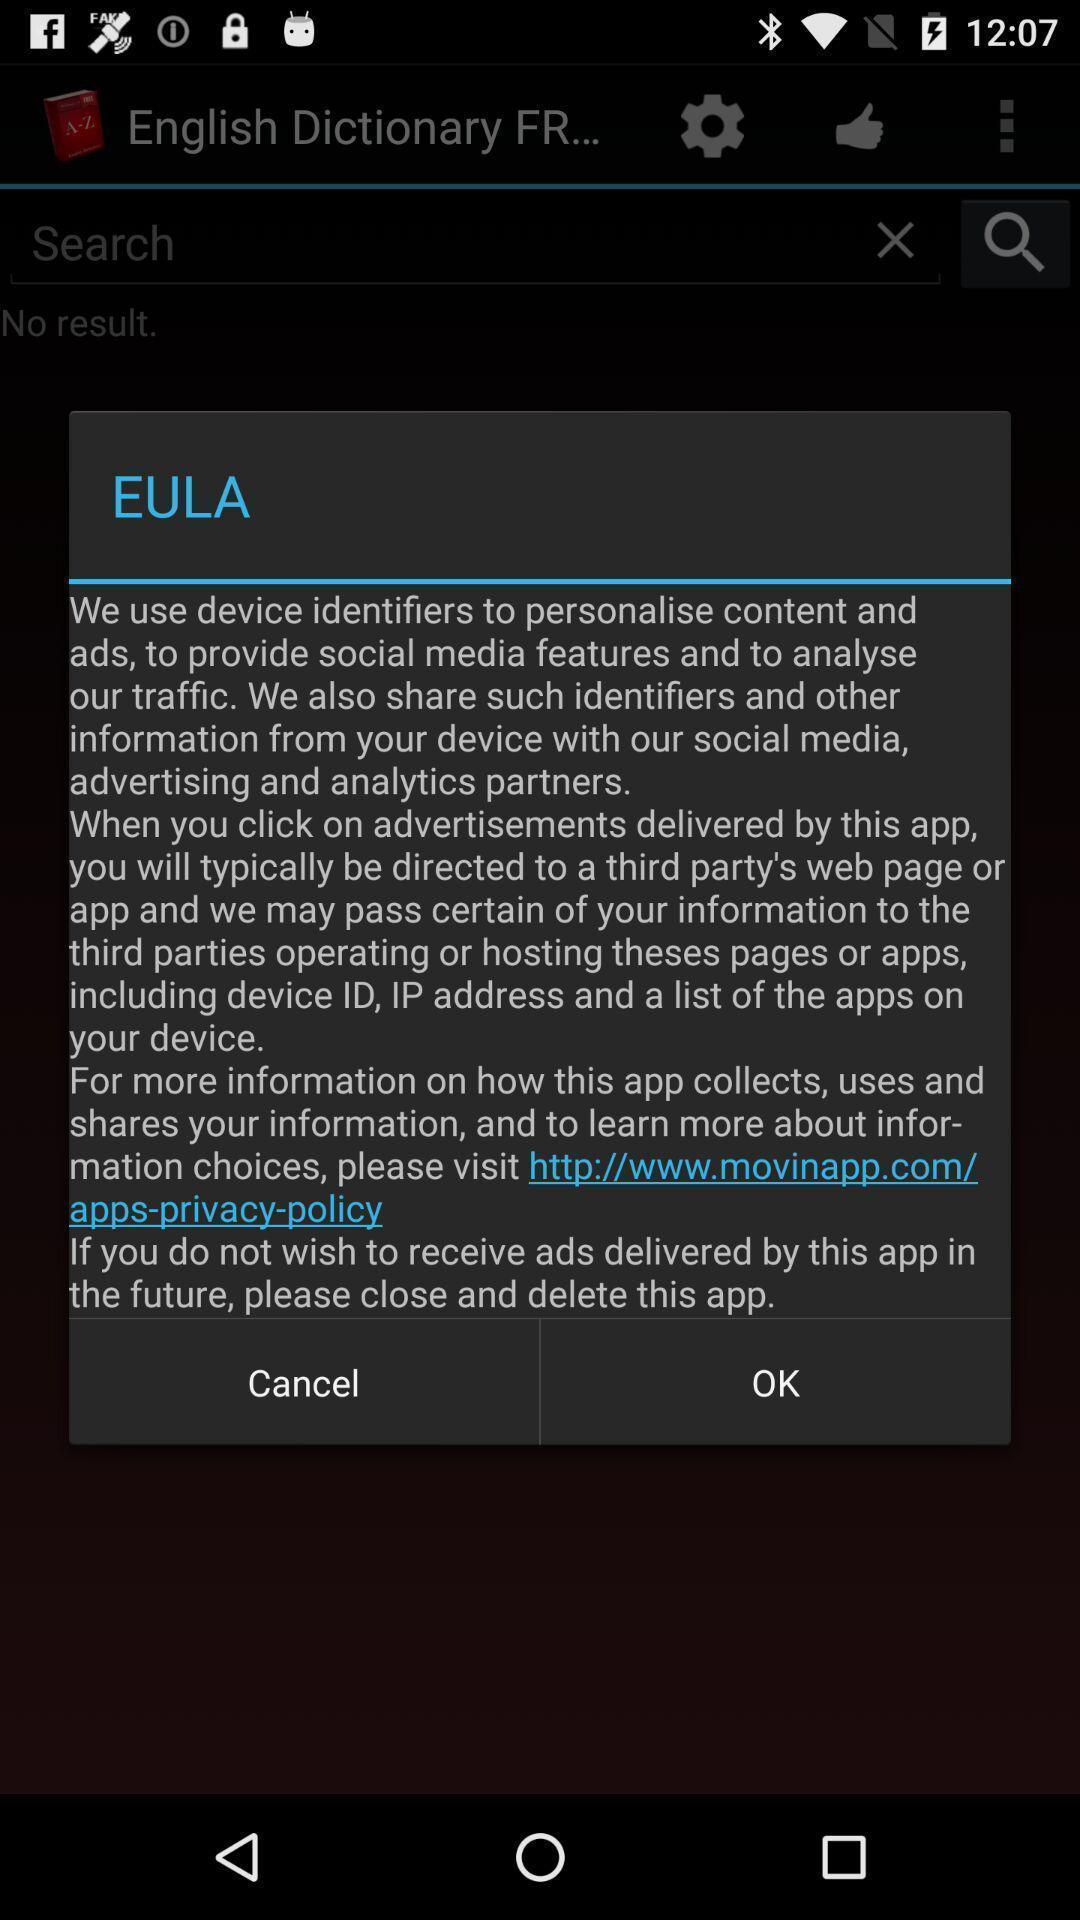Describe the key features of this screenshot. Pop-up page displaying with information about application. 